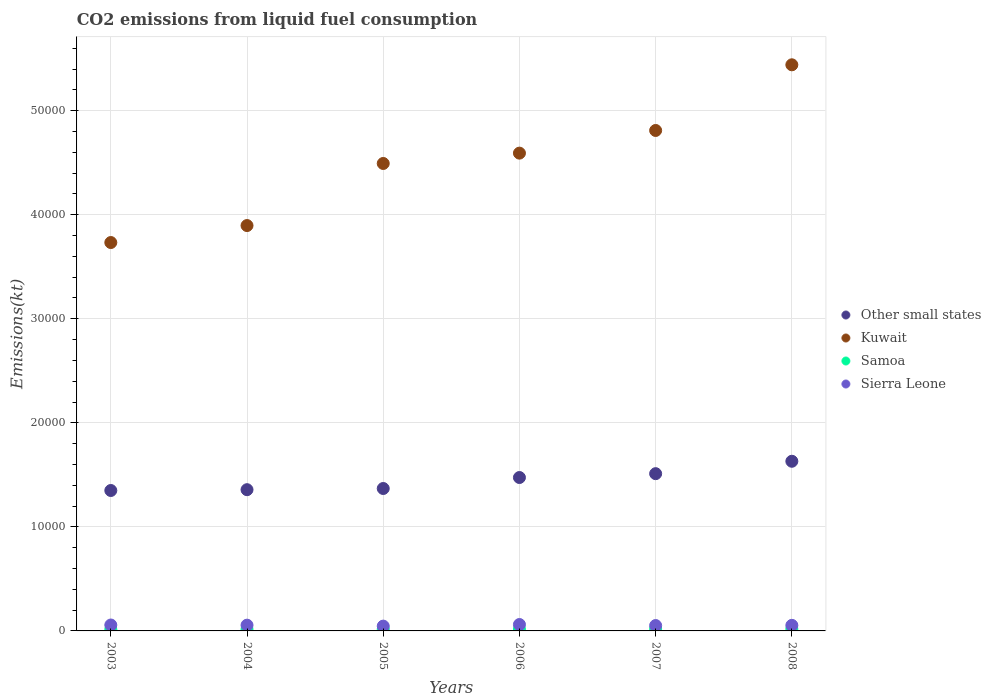How many different coloured dotlines are there?
Your response must be concise. 4. What is the amount of CO2 emitted in Samoa in 2004?
Keep it short and to the point. 161.35. Across all years, what is the maximum amount of CO2 emitted in Other small states?
Offer a very short reply. 1.63e+04. Across all years, what is the minimum amount of CO2 emitted in Other small states?
Offer a very short reply. 1.35e+04. What is the total amount of CO2 emitted in Samoa in the graph?
Provide a succinct answer. 1034.09. What is the difference between the amount of CO2 emitted in Kuwait in 2005 and that in 2006?
Give a very brief answer. -993.76. What is the difference between the amount of CO2 emitted in Other small states in 2004 and the amount of CO2 emitted in Kuwait in 2003?
Your answer should be very brief. -2.38e+04. What is the average amount of CO2 emitted in Kuwait per year?
Your answer should be very brief. 4.49e+04. In the year 2006, what is the difference between the amount of CO2 emitted in Samoa and amount of CO2 emitted in Kuwait?
Make the answer very short. -4.57e+04. In how many years, is the amount of CO2 emitted in Samoa greater than 52000 kt?
Your response must be concise. 0. What is the ratio of the amount of CO2 emitted in Kuwait in 2004 to that in 2006?
Offer a terse response. 0.85. Is the amount of CO2 emitted in Kuwait in 2004 less than that in 2007?
Offer a very short reply. Yes. Is the difference between the amount of CO2 emitted in Samoa in 2004 and 2008 greater than the difference between the amount of CO2 emitted in Kuwait in 2004 and 2008?
Offer a very short reply. Yes. What is the difference between the highest and the second highest amount of CO2 emitted in Samoa?
Give a very brief answer. 3.67. What is the difference between the highest and the lowest amount of CO2 emitted in Kuwait?
Give a very brief answer. 1.71e+04. In how many years, is the amount of CO2 emitted in Kuwait greater than the average amount of CO2 emitted in Kuwait taken over all years?
Offer a very short reply. 3. Is the sum of the amount of CO2 emitted in Samoa in 2003 and 2005 greater than the maximum amount of CO2 emitted in Other small states across all years?
Your response must be concise. No. Is it the case that in every year, the sum of the amount of CO2 emitted in Kuwait and amount of CO2 emitted in Samoa  is greater than the amount of CO2 emitted in Sierra Leone?
Offer a terse response. Yes. Does the amount of CO2 emitted in Kuwait monotonically increase over the years?
Provide a succinct answer. Yes. Is the amount of CO2 emitted in Sierra Leone strictly less than the amount of CO2 emitted in Kuwait over the years?
Your response must be concise. Yes. How many years are there in the graph?
Your response must be concise. 6. Are the values on the major ticks of Y-axis written in scientific E-notation?
Ensure brevity in your answer.  No. What is the title of the graph?
Offer a terse response. CO2 emissions from liquid fuel consumption. What is the label or title of the X-axis?
Offer a very short reply. Years. What is the label or title of the Y-axis?
Ensure brevity in your answer.  Emissions(kt). What is the Emissions(kt) of Other small states in 2003?
Your response must be concise. 1.35e+04. What is the Emissions(kt) in Kuwait in 2003?
Make the answer very short. 3.73e+04. What is the Emissions(kt) of Samoa in 2003?
Make the answer very short. 150.35. What is the Emissions(kt) of Sierra Leone in 2003?
Your answer should be compact. 568.38. What is the Emissions(kt) of Other small states in 2004?
Your answer should be compact. 1.36e+04. What is the Emissions(kt) of Kuwait in 2004?
Keep it short and to the point. 3.90e+04. What is the Emissions(kt) of Samoa in 2004?
Make the answer very short. 161.35. What is the Emissions(kt) in Sierra Leone in 2004?
Provide a short and direct response. 553.72. What is the Emissions(kt) of Other small states in 2005?
Give a very brief answer. 1.37e+04. What is the Emissions(kt) in Kuwait in 2005?
Keep it short and to the point. 4.49e+04. What is the Emissions(kt) in Samoa in 2005?
Provide a short and direct response. 168.68. What is the Emissions(kt) of Sierra Leone in 2005?
Give a very brief answer. 462.04. What is the Emissions(kt) in Other small states in 2006?
Provide a short and direct response. 1.47e+04. What is the Emissions(kt) of Kuwait in 2006?
Ensure brevity in your answer.  4.59e+04. What is the Emissions(kt) in Samoa in 2006?
Keep it short and to the point. 176.02. What is the Emissions(kt) of Sierra Leone in 2006?
Your answer should be very brief. 616.06. What is the Emissions(kt) of Other small states in 2007?
Give a very brief answer. 1.51e+04. What is the Emissions(kt) of Kuwait in 2007?
Make the answer very short. 4.81e+04. What is the Emissions(kt) in Samoa in 2007?
Your answer should be very brief. 187.02. What is the Emissions(kt) in Sierra Leone in 2007?
Your answer should be very brief. 517.05. What is the Emissions(kt) in Other small states in 2008?
Offer a terse response. 1.63e+04. What is the Emissions(kt) of Kuwait in 2008?
Ensure brevity in your answer.  5.44e+04. What is the Emissions(kt) of Samoa in 2008?
Your response must be concise. 190.68. What is the Emissions(kt) of Sierra Leone in 2008?
Offer a terse response. 535.38. Across all years, what is the maximum Emissions(kt) in Other small states?
Your answer should be very brief. 1.63e+04. Across all years, what is the maximum Emissions(kt) in Kuwait?
Offer a terse response. 5.44e+04. Across all years, what is the maximum Emissions(kt) in Samoa?
Your response must be concise. 190.68. Across all years, what is the maximum Emissions(kt) of Sierra Leone?
Your response must be concise. 616.06. Across all years, what is the minimum Emissions(kt) in Other small states?
Make the answer very short. 1.35e+04. Across all years, what is the minimum Emissions(kt) in Kuwait?
Your response must be concise. 3.73e+04. Across all years, what is the minimum Emissions(kt) of Samoa?
Your response must be concise. 150.35. Across all years, what is the minimum Emissions(kt) of Sierra Leone?
Your answer should be very brief. 462.04. What is the total Emissions(kt) of Other small states in the graph?
Your answer should be compact. 8.69e+04. What is the total Emissions(kt) of Kuwait in the graph?
Give a very brief answer. 2.70e+05. What is the total Emissions(kt) of Samoa in the graph?
Provide a short and direct response. 1034.09. What is the total Emissions(kt) of Sierra Leone in the graph?
Give a very brief answer. 3252.63. What is the difference between the Emissions(kt) of Other small states in 2003 and that in 2004?
Your answer should be compact. -78.53. What is the difference between the Emissions(kt) in Kuwait in 2003 and that in 2004?
Keep it short and to the point. -1631.82. What is the difference between the Emissions(kt) of Samoa in 2003 and that in 2004?
Provide a succinct answer. -11. What is the difference between the Emissions(kt) of Sierra Leone in 2003 and that in 2004?
Offer a terse response. 14.67. What is the difference between the Emissions(kt) of Other small states in 2003 and that in 2005?
Offer a terse response. -192.39. What is the difference between the Emissions(kt) in Kuwait in 2003 and that in 2005?
Your response must be concise. -7598.02. What is the difference between the Emissions(kt) of Samoa in 2003 and that in 2005?
Offer a very short reply. -18.34. What is the difference between the Emissions(kt) of Sierra Leone in 2003 and that in 2005?
Give a very brief answer. 106.34. What is the difference between the Emissions(kt) in Other small states in 2003 and that in 2006?
Keep it short and to the point. -1247.91. What is the difference between the Emissions(kt) in Kuwait in 2003 and that in 2006?
Your answer should be very brief. -8591.78. What is the difference between the Emissions(kt) in Samoa in 2003 and that in 2006?
Your response must be concise. -25.67. What is the difference between the Emissions(kt) in Sierra Leone in 2003 and that in 2006?
Provide a short and direct response. -47.67. What is the difference between the Emissions(kt) of Other small states in 2003 and that in 2007?
Your answer should be compact. -1617.54. What is the difference between the Emissions(kt) in Kuwait in 2003 and that in 2007?
Provide a succinct answer. -1.08e+04. What is the difference between the Emissions(kt) in Samoa in 2003 and that in 2007?
Your answer should be very brief. -36.67. What is the difference between the Emissions(kt) in Sierra Leone in 2003 and that in 2007?
Provide a succinct answer. 51.34. What is the difference between the Emissions(kt) in Other small states in 2003 and that in 2008?
Give a very brief answer. -2809.63. What is the difference between the Emissions(kt) in Kuwait in 2003 and that in 2008?
Offer a terse response. -1.71e+04. What is the difference between the Emissions(kt) in Samoa in 2003 and that in 2008?
Your answer should be very brief. -40.34. What is the difference between the Emissions(kt) of Sierra Leone in 2003 and that in 2008?
Give a very brief answer. 33. What is the difference between the Emissions(kt) in Other small states in 2004 and that in 2005?
Provide a short and direct response. -113.87. What is the difference between the Emissions(kt) of Kuwait in 2004 and that in 2005?
Provide a short and direct response. -5966.21. What is the difference between the Emissions(kt) of Samoa in 2004 and that in 2005?
Offer a very short reply. -7.33. What is the difference between the Emissions(kt) of Sierra Leone in 2004 and that in 2005?
Your answer should be compact. 91.67. What is the difference between the Emissions(kt) of Other small states in 2004 and that in 2006?
Make the answer very short. -1169.38. What is the difference between the Emissions(kt) in Kuwait in 2004 and that in 2006?
Provide a succinct answer. -6959.97. What is the difference between the Emissions(kt) in Samoa in 2004 and that in 2006?
Ensure brevity in your answer.  -14.67. What is the difference between the Emissions(kt) of Sierra Leone in 2004 and that in 2006?
Provide a succinct answer. -62.34. What is the difference between the Emissions(kt) in Other small states in 2004 and that in 2007?
Ensure brevity in your answer.  -1539.01. What is the difference between the Emissions(kt) in Kuwait in 2004 and that in 2007?
Your answer should be very brief. -9138.16. What is the difference between the Emissions(kt) in Samoa in 2004 and that in 2007?
Give a very brief answer. -25.67. What is the difference between the Emissions(kt) in Sierra Leone in 2004 and that in 2007?
Provide a succinct answer. 36.67. What is the difference between the Emissions(kt) of Other small states in 2004 and that in 2008?
Your response must be concise. -2731.1. What is the difference between the Emissions(kt) in Kuwait in 2004 and that in 2008?
Make the answer very short. -1.54e+04. What is the difference between the Emissions(kt) of Samoa in 2004 and that in 2008?
Make the answer very short. -29.34. What is the difference between the Emissions(kt) in Sierra Leone in 2004 and that in 2008?
Your response must be concise. 18.34. What is the difference between the Emissions(kt) in Other small states in 2005 and that in 2006?
Ensure brevity in your answer.  -1055.52. What is the difference between the Emissions(kt) of Kuwait in 2005 and that in 2006?
Offer a terse response. -993.76. What is the difference between the Emissions(kt) of Samoa in 2005 and that in 2006?
Offer a terse response. -7.33. What is the difference between the Emissions(kt) in Sierra Leone in 2005 and that in 2006?
Make the answer very short. -154.01. What is the difference between the Emissions(kt) of Other small states in 2005 and that in 2007?
Provide a succinct answer. -1425.14. What is the difference between the Emissions(kt) of Kuwait in 2005 and that in 2007?
Your answer should be compact. -3171.95. What is the difference between the Emissions(kt) in Samoa in 2005 and that in 2007?
Give a very brief answer. -18.34. What is the difference between the Emissions(kt) in Sierra Leone in 2005 and that in 2007?
Provide a short and direct response. -55.01. What is the difference between the Emissions(kt) in Other small states in 2005 and that in 2008?
Your answer should be very brief. -2617.24. What is the difference between the Emissions(kt) of Kuwait in 2005 and that in 2008?
Give a very brief answer. -9482.86. What is the difference between the Emissions(kt) of Samoa in 2005 and that in 2008?
Provide a short and direct response. -22. What is the difference between the Emissions(kt) in Sierra Leone in 2005 and that in 2008?
Provide a short and direct response. -73.34. What is the difference between the Emissions(kt) of Other small states in 2006 and that in 2007?
Make the answer very short. -369.62. What is the difference between the Emissions(kt) in Kuwait in 2006 and that in 2007?
Provide a short and direct response. -2178.2. What is the difference between the Emissions(kt) of Samoa in 2006 and that in 2007?
Give a very brief answer. -11. What is the difference between the Emissions(kt) in Sierra Leone in 2006 and that in 2007?
Give a very brief answer. 99.01. What is the difference between the Emissions(kt) in Other small states in 2006 and that in 2008?
Provide a short and direct response. -1561.72. What is the difference between the Emissions(kt) of Kuwait in 2006 and that in 2008?
Your answer should be very brief. -8489.1. What is the difference between the Emissions(kt) in Samoa in 2006 and that in 2008?
Keep it short and to the point. -14.67. What is the difference between the Emissions(kt) in Sierra Leone in 2006 and that in 2008?
Give a very brief answer. 80.67. What is the difference between the Emissions(kt) of Other small states in 2007 and that in 2008?
Keep it short and to the point. -1192.1. What is the difference between the Emissions(kt) of Kuwait in 2007 and that in 2008?
Offer a very short reply. -6310.91. What is the difference between the Emissions(kt) of Samoa in 2007 and that in 2008?
Offer a very short reply. -3.67. What is the difference between the Emissions(kt) of Sierra Leone in 2007 and that in 2008?
Provide a succinct answer. -18.34. What is the difference between the Emissions(kt) in Other small states in 2003 and the Emissions(kt) in Kuwait in 2004?
Make the answer very short. -2.55e+04. What is the difference between the Emissions(kt) in Other small states in 2003 and the Emissions(kt) in Samoa in 2004?
Provide a short and direct response. 1.33e+04. What is the difference between the Emissions(kt) of Other small states in 2003 and the Emissions(kt) of Sierra Leone in 2004?
Your answer should be very brief. 1.29e+04. What is the difference between the Emissions(kt) of Kuwait in 2003 and the Emissions(kt) of Samoa in 2004?
Give a very brief answer. 3.72e+04. What is the difference between the Emissions(kt) in Kuwait in 2003 and the Emissions(kt) in Sierra Leone in 2004?
Provide a short and direct response. 3.68e+04. What is the difference between the Emissions(kt) in Samoa in 2003 and the Emissions(kt) in Sierra Leone in 2004?
Offer a very short reply. -403.37. What is the difference between the Emissions(kt) of Other small states in 2003 and the Emissions(kt) of Kuwait in 2005?
Your answer should be very brief. -3.14e+04. What is the difference between the Emissions(kt) of Other small states in 2003 and the Emissions(kt) of Samoa in 2005?
Provide a short and direct response. 1.33e+04. What is the difference between the Emissions(kt) in Other small states in 2003 and the Emissions(kt) in Sierra Leone in 2005?
Offer a very short reply. 1.30e+04. What is the difference between the Emissions(kt) in Kuwait in 2003 and the Emissions(kt) in Samoa in 2005?
Give a very brief answer. 3.72e+04. What is the difference between the Emissions(kt) in Kuwait in 2003 and the Emissions(kt) in Sierra Leone in 2005?
Give a very brief answer. 3.69e+04. What is the difference between the Emissions(kt) in Samoa in 2003 and the Emissions(kt) in Sierra Leone in 2005?
Make the answer very short. -311.69. What is the difference between the Emissions(kt) of Other small states in 2003 and the Emissions(kt) of Kuwait in 2006?
Offer a terse response. -3.24e+04. What is the difference between the Emissions(kt) of Other small states in 2003 and the Emissions(kt) of Samoa in 2006?
Keep it short and to the point. 1.33e+04. What is the difference between the Emissions(kt) of Other small states in 2003 and the Emissions(kt) of Sierra Leone in 2006?
Provide a succinct answer. 1.29e+04. What is the difference between the Emissions(kt) in Kuwait in 2003 and the Emissions(kt) in Samoa in 2006?
Make the answer very short. 3.72e+04. What is the difference between the Emissions(kt) in Kuwait in 2003 and the Emissions(kt) in Sierra Leone in 2006?
Your answer should be compact. 3.67e+04. What is the difference between the Emissions(kt) of Samoa in 2003 and the Emissions(kt) of Sierra Leone in 2006?
Offer a very short reply. -465.71. What is the difference between the Emissions(kt) of Other small states in 2003 and the Emissions(kt) of Kuwait in 2007?
Offer a very short reply. -3.46e+04. What is the difference between the Emissions(kt) of Other small states in 2003 and the Emissions(kt) of Samoa in 2007?
Make the answer very short. 1.33e+04. What is the difference between the Emissions(kt) in Other small states in 2003 and the Emissions(kt) in Sierra Leone in 2007?
Offer a terse response. 1.30e+04. What is the difference between the Emissions(kt) in Kuwait in 2003 and the Emissions(kt) in Samoa in 2007?
Your answer should be compact. 3.71e+04. What is the difference between the Emissions(kt) of Kuwait in 2003 and the Emissions(kt) of Sierra Leone in 2007?
Make the answer very short. 3.68e+04. What is the difference between the Emissions(kt) of Samoa in 2003 and the Emissions(kt) of Sierra Leone in 2007?
Your answer should be very brief. -366.7. What is the difference between the Emissions(kt) in Other small states in 2003 and the Emissions(kt) in Kuwait in 2008?
Keep it short and to the point. -4.09e+04. What is the difference between the Emissions(kt) of Other small states in 2003 and the Emissions(kt) of Samoa in 2008?
Provide a short and direct response. 1.33e+04. What is the difference between the Emissions(kt) of Other small states in 2003 and the Emissions(kt) of Sierra Leone in 2008?
Keep it short and to the point. 1.30e+04. What is the difference between the Emissions(kt) of Kuwait in 2003 and the Emissions(kt) of Samoa in 2008?
Your answer should be very brief. 3.71e+04. What is the difference between the Emissions(kt) of Kuwait in 2003 and the Emissions(kt) of Sierra Leone in 2008?
Give a very brief answer. 3.68e+04. What is the difference between the Emissions(kt) in Samoa in 2003 and the Emissions(kt) in Sierra Leone in 2008?
Make the answer very short. -385.04. What is the difference between the Emissions(kt) in Other small states in 2004 and the Emissions(kt) in Kuwait in 2005?
Offer a very short reply. -3.14e+04. What is the difference between the Emissions(kt) of Other small states in 2004 and the Emissions(kt) of Samoa in 2005?
Keep it short and to the point. 1.34e+04. What is the difference between the Emissions(kt) in Other small states in 2004 and the Emissions(kt) in Sierra Leone in 2005?
Your answer should be very brief. 1.31e+04. What is the difference between the Emissions(kt) in Kuwait in 2004 and the Emissions(kt) in Samoa in 2005?
Provide a succinct answer. 3.88e+04. What is the difference between the Emissions(kt) of Kuwait in 2004 and the Emissions(kt) of Sierra Leone in 2005?
Your answer should be very brief. 3.85e+04. What is the difference between the Emissions(kt) of Samoa in 2004 and the Emissions(kt) of Sierra Leone in 2005?
Provide a short and direct response. -300.69. What is the difference between the Emissions(kt) of Other small states in 2004 and the Emissions(kt) of Kuwait in 2006?
Your response must be concise. -3.23e+04. What is the difference between the Emissions(kt) of Other small states in 2004 and the Emissions(kt) of Samoa in 2006?
Keep it short and to the point. 1.34e+04. What is the difference between the Emissions(kt) in Other small states in 2004 and the Emissions(kt) in Sierra Leone in 2006?
Offer a very short reply. 1.30e+04. What is the difference between the Emissions(kt) of Kuwait in 2004 and the Emissions(kt) of Samoa in 2006?
Offer a very short reply. 3.88e+04. What is the difference between the Emissions(kt) of Kuwait in 2004 and the Emissions(kt) of Sierra Leone in 2006?
Your answer should be compact. 3.83e+04. What is the difference between the Emissions(kt) in Samoa in 2004 and the Emissions(kt) in Sierra Leone in 2006?
Ensure brevity in your answer.  -454.71. What is the difference between the Emissions(kt) in Other small states in 2004 and the Emissions(kt) in Kuwait in 2007?
Your answer should be compact. -3.45e+04. What is the difference between the Emissions(kt) of Other small states in 2004 and the Emissions(kt) of Samoa in 2007?
Your answer should be very brief. 1.34e+04. What is the difference between the Emissions(kt) in Other small states in 2004 and the Emissions(kt) in Sierra Leone in 2007?
Provide a succinct answer. 1.31e+04. What is the difference between the Emissions(kt) in Kuwait in 2004 and the Emissions(kt) in Samoa in 2007?
Ensure brevity in your answer.  3.88e+04. What is the difference between the Emissions(kt) of Kuwait in 2004 and the Emissions(kt) of Sierra Leone in 2007?
Provide a short and direct response. 3.84e+04. What is the difference between the Emissions(kt) in Samoa in 2004 and the Emissions(kt) in Sierra Leone in 2007?
Give a very brief answer. -355.7. What is the difference between the Emissions(kt) in Other small states in 2004 and the Emissions(kt) in Kuwait in 2008?
Your answer should be very brief. -4.08e+04. What is the difference between the Emissions(kt) of Other small states in 2004 and the Emissions(kt) of Samoa in 2008?
Ensure brevity in your answer.  1.34e+04. What is the difference between the Emissions(kt) of Other small states in 2004 and the Emissions(kt) of Sierra Leone in 2008?
Provide a succinct answer. 1.30e+04. What is the difference between the Emissions(kt) in Kuwait in 2004 and the Emissions(kt) in Samoa in 2008?
Ensure brevity in your answer.  3.88e+04. What is the difference between the Emissions(kt) of Kuwait in 2004 and the Emissions(kt) of Sierra Leone in 2008?
Your response must be concise. 3.84e+04. What is the difference between the Emissions(kt) of Samoa in 2004 and the Emissions(kt) of Sierra Leone in 2008?
Your answer should be compact. -374.03. What is the difference between the Emissions(kt) of Other small states in 2005 and the Emissions(kt) of Kuwait in 2006?
Offer a very short reply. -3.22e+04. What is the difference between the Emissions(kt) of Other small states in 2005 and the Emissions(kt) of Samoa in 2006?
Your answer should be compact. 1.35e+04. What is the difference between the Emissions(kt) of Other small states in 2005 and the Emissions(kt) of Sierra Leone in 2006?
Ensure brevity in your answer.  1.31e+04. What is the difference between the Emissions(kt) in Kuwait in 2005 and the Emissions(kt) in Samoa in 2006?
Keep it short and to the point. 4.47e+04. What is the difference between the Emissions(kt) of Kuwait in 2005 and the Emissions(kt) of Sierra Leone in 2006?
Keep it short and to the point. 4.43e+04. What is the difference between the Emissions(kt) in Samoa in 2005 and the Emissions(kt) in Sierra Leone in 2006?
Provide a short and direct response. -447.37. What is the difference between the Emissions(kt) of Other small states in 2005 and the Emissions(kt) of Kuwait in 2007?
Your answer should be compact. -3.44e+04. What is the difference between the Emissions(kt) in Other small states in 2005 and the Emissions(kt) in Samoa in 2007?
Provide a succinct answer. 1.35e+04. What is the difference between the Emissions(kt) of Other small states in 2005 and the Emissions(kt) of Sierra Leone in 2007?
Provide a short and direct response. 1.32e+04. What is the difference between the Emissions(kt) in Kuwait in 2005 and the Emissions(kt) in Samoa in 2007?
Your answer should be very brief. 4.47e+04. What is the difference between the Emissions(kt) of Kuwait in 2005 and the Emissions(kt) of Sierra Leone in 2007?
Provide a short and direct response. 4.44e+04. What is the difference between the Emissions(kt) of Samoa in 2005 and the Emissions(kt) of Sierra Leone in 2007?
Provide a succinct answer. -348.37. What is the difference between the Emissions(kt) in Other small states in 2005 and the Emissions(kt) in Kuwait in 2008?
Keep it short and to the point. -4.07e+04. What is the difference between the Emissions(kt) of Other small states in 2005 and the Emissions(kt) of Samoa in 2008?
Provide a short and direct response. 1.35e+04. What is the difference between the Emissions(kt) in Other small states in 2005 and the Emissions(kt) in Sierra Leone in 2008?
Ensure brevity in your answer.  1.32e+04. What is the difference between the Emissions(kt) of Kuwait in 2005 and the Emissions(kt) of Samoa in 2008?
Offer a very short reply. 4.47e+04. What is the difference between the Emissions(kt) in Kuwait in 2005 and the Emissions(kt) in Sierra Leone in 2008?
Make the answer very short. 4.44e+04. What is the difference between the Emissions(kt) in Samoa in 2005 and the Emissions(kt) in Sierra Leone in 2008?
Your answer should be compact. -366.7. What is the difference between the Emissions(kt) of Other small states in 2006 and the Emissions(kt) of Kuwait in 2007?
Offer a very short reply. -3.34e+04. What is the difference between the Emissions(kt) of Other small states in 2006 and the Emissions(kt) of Samoa in 2007?
Ensure brevity in your answer.  1.46e+04. What is the difference between the Emissions(kt) of Other small states in 2006 and the Emissions(kt) of Sierra Leone in 2007?
Make the answer very short. 1.42e+04. What is the difference between the Emissions(kt) in Kuwait in 2006 and the Emissions(kt) in Samoa in 2007?
Provide a succinct answer. 4.57e+04. What is the difference between the Emissions(kt) in Kuwait in 2006 and the Emissions(kt) in Sierra Leone in 2007?
Your answer should be compact. 4.54e+04. What is the difference between the Emissions(kt) in Samoa in 2006 and the Emissions(kt) in Sierra Leone in 2007?
Give a very brief answer. -341.03. What is the difference between the Emissions(kt) of Other small states in 2006 and the Emissions(kt) of Kuwait in 2008?
Ensure brevity in your answer.  -3.97e+04. What is the difference between the Emissions(kt) of Other small states in 2006 and the Emissions(kt) of Samoa in 2008?
Provide a short and direct response. 1.46e+04. What is the difference between the Emissions(kt) in Other small states in 2006 and the Emissions(kt) in Sierra Leone in 2008?
Make the answer very short. 1.42e+04. What is the difference between the Emissions(kt) of Kuwait in 2006 and the Emissions(kt) of Samoa in 2008?
Offer a very short reply. 4.57e+04. What is the difference between the Emissions(kt) of Kuwait in 2006 and the Emissions(kt) of Sierra Leone in 2008?
Make the answer very short. 4.54e+04. What is the difference between the Emissions(kt) of Samoa in 2006 and the Emissions(kt) of Sierra Leone in 2008?
Offer a terse response. -359.37. What is the difference between the Emissions(kt) in Other small states in 2007 and the Emissions(kt) in Kuwait in 2008?
Your answer should be very brief. -3.93e+04. What is the difference between the Emissions(kt) in Other small states in 2007 and the Emissions(kt) in Samoa in 2008?
Your answer should be very brief. 1.49e+04. What is the difference between the Emissions(kt) of Other small states in 2007 and the Emissions(kt) of Sierra Leone in 2008?
Offer a very short reply. 1.46e+04. What is the difference between the Emissions(kt) in Kuwait in 2007 and the Emissions(kt) in Samoa in 2008?
Keep it short and to the point. 4.79e+04. What is the difference between the Emissions(kt) in Kuwait in 2007 and the Emissions(kt) in Sierra Leone in 2008?
Offer a terse response. 4.76e+04. What is the difference between the Emissions(kt) in Samoa in 2007 and the Emissions(kt) in Sierra Leone in 2008?
Provide a short and direct response. -348.37. What is the average Emissions(kt) in Other small states per year?
Keep it short and to the point. 1.45e+04. What is the average Emissions(kt) in Kuwait per year?
Keep it short and to the point. 4.49e+04. What is the average Emissions(kt) in Samoa per year?
Your response must be concise. 172.35. What is the average Emissions(kt) in Sierra Leone per year?
Your answer should be compact. 542.1. In the year 2003, what is the difference between the Emissions(kt) of Other small states and Emissions(kt) of Kuwait?
Give a very brief answer. -2.38e+04. In the year 2003, what is the difference between the Emissions(kt) of Other small states and Emissions(kt) of Samoa?
Give a very brief answer. 1.33e+04. In the year 2003, what is the difference between the Emissions(kt) of Other small states and Emissions(kt) of Sierra Leone?
Ensure brevity in your answer.  1.29e+04. In the year 2003, what is the difference between the Emissions(kt) of Kuwait and Emissions(kt) of Samoa?
Your answer should be very brief. 3.72e+04. In the year 2003, what is the difference between the Emissions(kt) of Kuwait and Emissions(kt) of Sierra Leone?
Ensure brevity in your answer.  3.68e+04. In the year 2003, what is the difference between the Emissions(kt) of Samoa and Emissions(kt) of Sierra Leone?
Provide a succinct answer. -418.04. In the year 2004, what is the difference between the Emissions(kt) of Other small states and Emissions(kt) of Kuwait?
Offer a very short reply. -2.54e+04. In the year 2004, what is the difference between the Emissions(kt) in Other small states and Emissions(kt) in Samoa?
Your answer should be compact. 1.34e+04. In the year 2004, what is the difference between the Emissions(kt) of Other small states and Emissions(kt) of Sierra Leone?
Your answer should be very brief. 1.30e+04. In the year 2004, what is the difference between the Emissions(kt) in Kuwait and Emissions(kt) in Samoa?
Offer a terse response. 3.88e+04. In the year 2004, what is the difference between the Emissions(kt) in Kuwait and Emissions(kt) in Sierra Leone?
Offer a terse response. 3.84e+04. In the year 2004, what is the difference between the Emissions(kt) of Samoa and Emissions(kt) of Sierra Leone?
Provide a short and direct response. -392.37. In the year 2005, what is the difference between the Emissions(kt) in Other small states and Emissions(kt) in Kuwait?
Offer a very short reply. -3.12e+04. In the year 2005, what is the difference between the Emissions(kt) in Other small states and Emissions(kt) in Samoa?
Your answer should be very brief. 1.35e+04. In the year 2005, what is the difference between the Emissions(kt) of Other small states and Emissions(kt) of Sierra Leone?
Give a very brief answer. 1.32e+04. In the year 2005, what is the difference between the Emissions(kt) of Kuwait and Emissions(kt) of Samoa?
Offer a terse response. 4.48e+04. In the year 2005, what is the difference between the Emissions(kt) of Kuwait and Emissions(kt) of Sierra Leone?
Your answer should be compact. 4.45e+04. In the year 2005, what is the difference between the Emissions(kt) in Samoa and Emissions(kt) in Sierra Leone?
Keep it short and to the point. -293.36. In the year 2006, what is the difference between the Emissions(kt) of Other small states and Emissions(kt) of Kuwait?
Provide a succinct answer. -3.12e+04. In the year 2006, what is the difference between the Emissions(kt) in Other small states and Emissions(kt) in Samoa?
Make the answer very short. 1.46e+04. In the year 2006, what is the difference between the Emissions(kt) of Other small states and Emissions(kt) of Sierra Leone?
Offer a very short reply. 1.41e+04. In the year 2006, what is the difference between the Emissions(kt) of Kuwait and Emissions(kt) of Samoa?
Your response must be concise. 4.57e+04. In the year 2006, what is the difference between the Emissions(kt) of Kuwait and Emissions(kt) of Sierra Leone?
Ensure brevity in your answer.  4.53e+04. In the year 2006, what is the difference between the Emissions(kt) of Samoa and Emissions(kt) of Sierra Leone?
Offer a very short reply. -440.04. In the year 2007, what is the difference between the Emissions(kt) in Other small states and Emissions(kt) in Kuwait?
Your answer should be compact. -3.30e+04. In the year 2007, what is the difference between the Emissions(kt) in Other small states and Emissions(kt) in Samoa?
Your answer should be compact. 1.49e+04. In the year 2007, what is the difference between the Emissions(kt) in Other small states and Emissions(kt) in Sierra Leone?
Make the answer very short. 1.46e+04. In the year 2007, what is the difference between the Emissions(kt) in Kuwait and Emissions(kt) in Samoa?
Provide a succinct answer. 4.79e+04. In the year 2007, what is the difference between the Emissions(kt) of Kuwait and Emissions(kt) of Sierra Leone?
Offer a terse response. 4.76e+04. In the year 2007, what is the difference between the Emissions(kt) of Samoa and Emissions(kt) of Sierra Leone?
Your response must be concise. -330.03. In the year 2008, what is the difference between the Emissions(kt) of Other small states and Emissions(kt) of Kuwait?
Provide a succinct answer. -3.81e+04. In the year 2008, what is the difference between the Emissions(kt) of Other small states and Emissions(kt) of Samoa?
Ensure brevity in your answer.  1.61e+04. In the year 2008, what is the difference between the Emissions(kt) of Other small states and Emissions(kt) of Sierra Leone?
Ensure brevity in your answer.  1.58e+04. In the year 2008, what is the difference between the Emissions(kt) in Kuwait and Emissions(kt) in Samoa?
Your answer should be compact. 5.42e+04. In the year 2008, what is the difference between the Emissions(kt) of Kuwait and Emissions(kt) of Sierra Leone?
Provide a short and direct response. 5.39e+04. In the year 2008, what is the difference between the Emissions(kt) in Samoa and Emissions(kt) in Sierra Leone?
Ensure brevity in your answer.  -344.7. What is the ratio of the Emissions(kt) in Other small states in 2003 to that in 2004?
Provide a short and direct response. 0.99. What is the ratio of the Emissions(kt) in Kuwait in 2003 to that in 2004?
Your response must be concise. 0.96. What is the ratio of the Emissions(kt) of Samoa in 2003 to that in 2004?
Keep it short and to the point. 0.93. What is the ratio of the Emissions(kt) in Sierra Leone in 2003 to that in 2004?
Offer a terse response. 1.03. What is the ratio of the Emissions(kt) in Other small states in 2003 to that in 2005?
Offer a terse response. 0.99. What is the ratio of the Emissions(kt) in Kuwait in 2003 to that in 2005?
Your response must be concise. 0.83. What is the ratio of the Emissions(kt) in Samoa in 2003 to that in 2005?
Offer a terse response. 0.89. What is the ratio of the Emissions(kt) of Sierra Leone in 2003 to that in 2005?
Make the answer very short. 1.23. What is the ratio of the Emissions(kt) of Other small states in 2003 to that in 2006?
Give a very brief answer. 0.92. What is the ratio of the Emissions(kt) of Kuwait in 2003 to that in 2006?
Keep it short and to the point. 0.81. What is the ratio of the Emissions(kt) in Samoa in 2003 to that in 2006?
Your answer should be compact. 0.85. What is the ratio of the Emissions(kt) of Sierra Leone in 2003 to that in 2006?
Your response must be concise. 0.92. What is the ratio of the Emissions(kt) in Other small states in 2003 to that in 2007?
Your response must be concise. 0.89. What is the ratio of the Emissions(kt) in Kuwait in 2003 to that in 2007?
Provide a short and direct response. 0.78. What is the ratio of the Emissions(kt) in Samoa in 2003 to that in 2007?
Your answer should be compact. 0.8. What is the ratio of the Emissions(kt) of Sierra Leone in 2003 to that in 2007?
Your answer should be compact. 1.1. What is the ratio of the Emissions(kt) in Other small states in 2003 to that in 2008?
Provide a short and direct response. 0.83. What is the ratio of the Emissions(kt) in Kuwait in 2003 to that in 2008?
Make the answer very short. 0.69. What is the ratio of the Emissions(kt) in Samoa in 2003 to that in 2008?
Offer a very short reply. 0.79. What is the ratio of the Emissions(kt) in Sierra Leone in 2003 to that in 2008?
Offer a terse response. 1.06. What is the ratio of the Emissions(kt) of Kuwait in 2004 to that in 2005?
Provide a succinct answer. 0.87. What is the ratio of the Emissions(kt) in Samoa in 2004 to that in 2005?
Your answer should be compact. 0.96. What is the ratio of the Emissions(kt) in Sierra Leone in 2004 to that in 2005?
Provide a succinct answer. 1.2. What is the ratio of the Emissions(kt) of Other small states in 2004 to that in 2006?
Offer a very short reply. 0.92. What is the ratio of the Emissions(kt) in Kuwait in 2004 to that in 2006?
Make the answer very short. 0.85. What is the ratio of the Emissions(kt) in Sierra Leone in 2004 to that in 2006?
Ensure brevity in your answer.  0.9. What is the ratio of the Emissions(kt) of Other small states in 2004 to that in 2007?
Your answer should be compact. 0.9. What is the ratio of the Emissions(kt) of Kuwait in 2004 to that in 2007?
Make the answer very short. 0.81. What is the ratio of the Emissions(kt) of Samoa in 2004 to that in 2007?
Provide a succinct answer. 0.86. What is the ratio of the Emissions(kt) of Sierra Leone in 2004 to that in 2007?
Make the answer very short. 1.07. What is the ratio of the Emissions(kt) in Other small states in 2004 to that in 2008?
Your answer should be very brief. 0.83. What is the ratio of the Emissions(kt) in Kuwait in 2004 to that in 2008?
Provide a short and direct response. 0.72. What is the ratio of the Emissions(kt) in Samoa in 2004 to that in 2008?
Give a very brief answer. 0.85. What is the ratio of the Emissions(kt) of Sierra Leone in 2004 to that in 2008?
Make the answer very short. 1.03. What is the ratio of the Emissions(kt) in Other small states in 2005 to that in 2006?
Offer a terse response. 0.93. What is the ratio of the Emissions(kt) of Kuwait in 2005 to that in 2006?
Provide a short and direct response. 0.98. What is the ratio of the Emissions(kt) in Sierra Leone in 2005 to that in 2006?
Your answer should be compact. 0.75. What is the ratio of the Emissions(kt) of Other small states in 2005 to that in 2007?
Provide a succinct answer. 0.91. What is the ratio of the Emissions(kt) of Kuwait in 2005 to that in 2007?
Offer a terse response. 0.93. What is the ratio of the Emissions(kt) in Samoa in 2005 to that in 2007?
Make the answer very short. 0.9. What is the ratio of the Emissions(kt) in Sierra Leone in 2005 to that in 2007?
Keep it short and to the point. 0.89. What is the ratio of the Emissions(kt) of Other small states in 2005 to that in 2008?
Offer a very short reply. 0.84. What is the ratio of the Emissions(kt) of Kuwait in 2005 to that in 2008?
Offer a terse response. 0.83. What is the ratio of the Emissions(kt) in Samoa in 2005 to that in 2008?
Make the answer very short. 0.88. What is the ratio of the Emissions(kt) in Sierra Leone in 2005 to that in 2008?
Give a very brief answer. 0.86. What is the ratio of the Emissions(kt) of Other small states in 2006 to that in 2007?
Keep it short and to the point. 0.98. What is the ratio of the Emissions(kt) of Kuwait in 2006 to that in 2007?
Your answer should be very brief. 0.95. What is the ratio of the Emissions(kt) of Samoa in 2006 to that in 2007?
Your answer should be very brief. 0.94. What is the ratio of the Emissions(kt) in Sierra Leone in 2006 to that in 2007?
Offer a terse response. 1.19. What is the ratio of the Emissions(kt) of Other small states in 2006 to that in 2008?
Make the answer very short. 0.9. What is the ratio of the Emissions(kt) of Kuwait in 2006 to that in 2008?
Ensure brevity in your answer.  0.84. What is the ratio of the Emissions(kt) of Sierra Leone in 2006 to that in 2008?
Your answer should be very brief. 1.15. What is the ratio of the Emissions(kt) of Other small states in 2007 to that in 2008?
Offer a very short reply. 0.93. What is the ratio of the Emissions(kt) of Kuwait in 2007 to that in 2008?
Offer a very short reply. 0.88. What is the ratio of the Emissions(kt) in Samoa in 2007 to that in 2008?
Provide a succinct answer. 0.98. What is the ratio of the Emissions(kt) of Sierra Leone in 2007 to that in 2008?
Give a very brief answer. 0.97. What is the difference between the highest and the second highest Emissions(kt) of Other small states?
Your answer should be very brief. 1192.1. What is the difference between the highest and the second highest Emissions(kt) of Kuwait?
Keep it short and to the point. 6310.91. What is the difference between the highest and the second highest Emissions(kt) of Samoa?
Keep it short and to the point. 3.67. What is the difference between the highest and the second highest Emissions(kt) of Sierra Leone?
Offer a terse response. 47.67. What is the difference between the highest and the lowest Emissions(kt) in Other small states?
Offer a terse response. 2809.63. What is the difference between the highest and the lowest Emissions(kt) in Kuwait?
Provide a succinct answer. 1.71e+04. What is the difference between the highest and the lowest Emissions(kt) of Samoa?
Your answer should be compact. 40.34. What is the difference between the highest and the lowest Emissions(kt) in Sierra Leone?
Give a very brief answer. 154.01. 